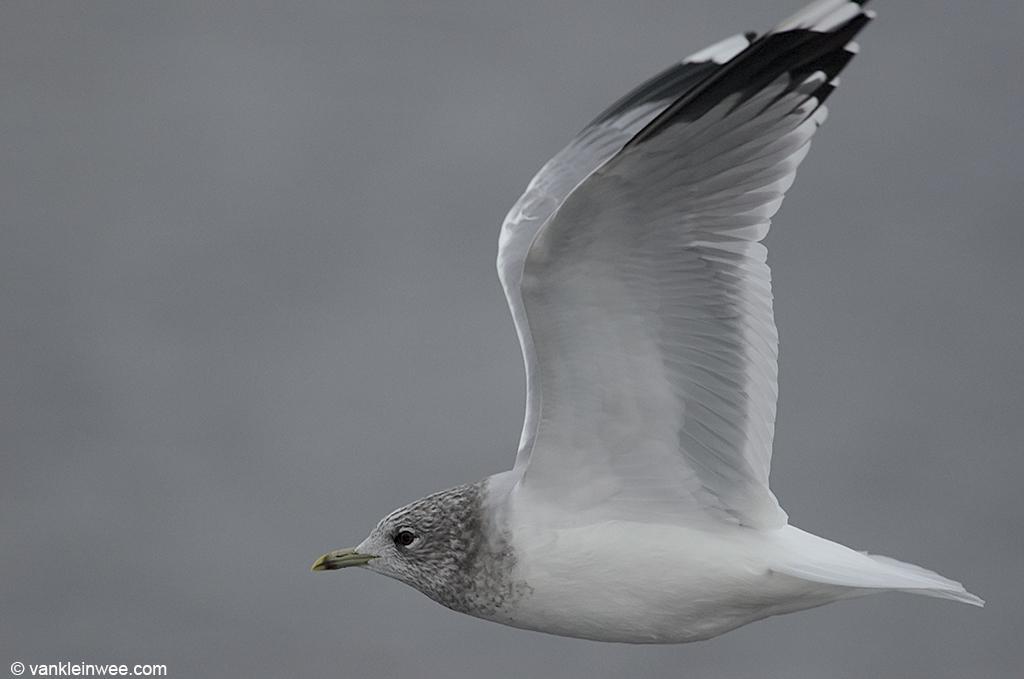How would you summarize this image in a sentence or two? This is a black and white picture. I can see a bird flying in the air, and there is blur background and there is a watermark on the image. 